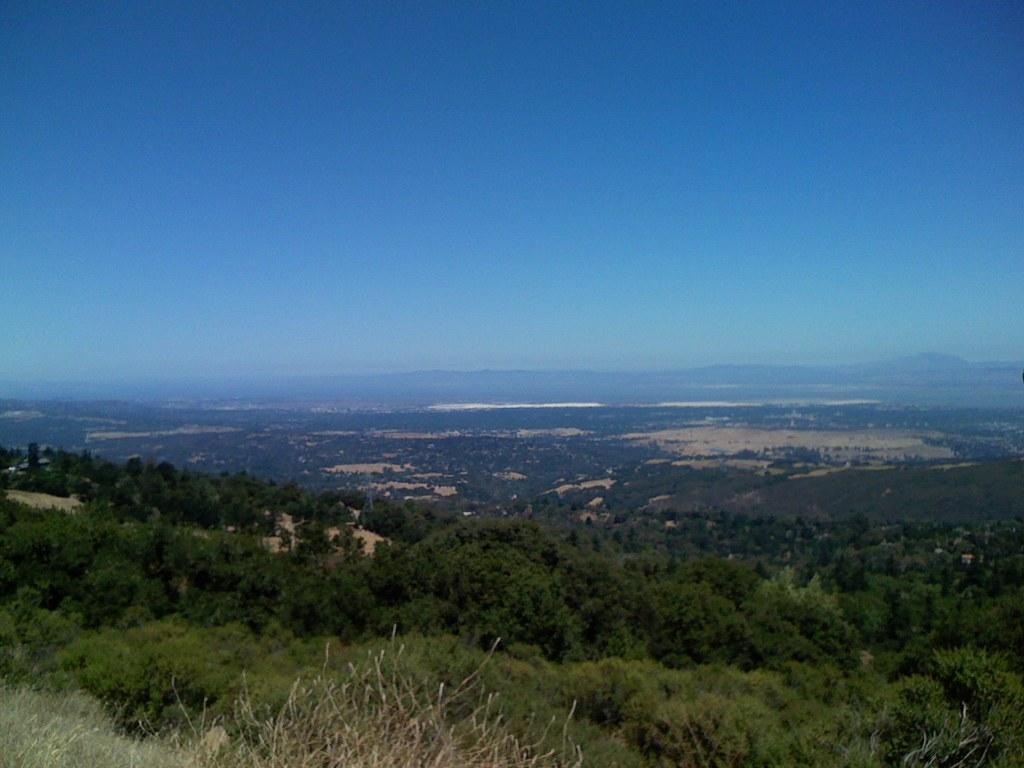What type of vegetation can be seen in the image? There are trees in the image. What natural features are visible in the background of the image? There are mountains visible in the background of the image. What is visible at the top of the image? The sky is visible at the top of the image. Can you hear the trees laughing in the image? Trees do not have the ability to laugh, so there is no laughter present in the image. Is there snow covering the mountains in the image? The provided facts do not mention snow, so we cannot determine if there is snow on the mountains in the image. 